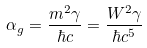Convert formula to latex. <formula><loc_0><loc_0><loc_500><loc_500>\alpha _ { g } = \frac { m ^ { 2 } \gamma } { \hbar { c } } = \frac { W ^ { 2 } \gamma } { \hbar { c } ^ { 5 } }</formula> 